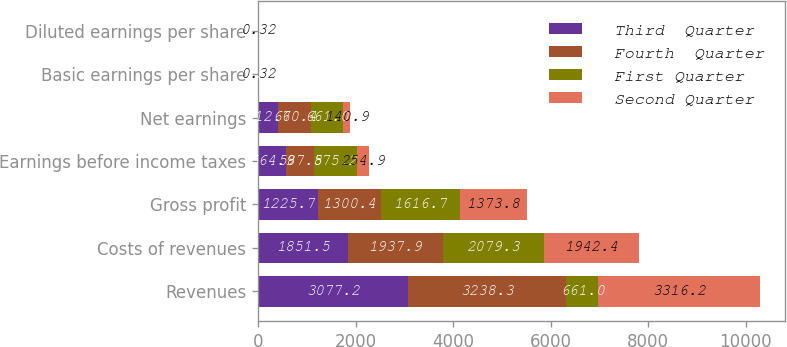Convert chart. <chart><loc_0><loc_0><loc_500><loc_500><stacked_bar_chart><ecel><fcel>Revenues<fcel>Costs of revenues<fcel>Gross profit<fcel>Earnings before income taxes<fcel>Net earnings<fcel>Basic earnings per share<fcel>Diluted earnings per share<nl><fcel>Third  Quarter<fcel>3077.2<fcel>1851.5<fcel>1225.7<fcel>564.9<fcel>412.6<fcel>0.93<fcel>0.93<nl><fcel>Fourth  Quarter<fcel>3238.3<fcel>1937.9<fcel>1300.4<fcel>587.5<fcel>670.4<fcel>1.52<fcel>1.51<nl><fcel>First Quarter<fcel>661<fcel>2079.3<fcel>1616.7<fcel>875.2<fcel>661<fcel>1.5<fcel>1.49<nl><fcel>Second Quarter<fcel>3316.2<fcel>1942.4<fcel>1373.8<fcel>254.9<fcel>140.9<fcel>0.32<fcel>0.32<nl></chart> 